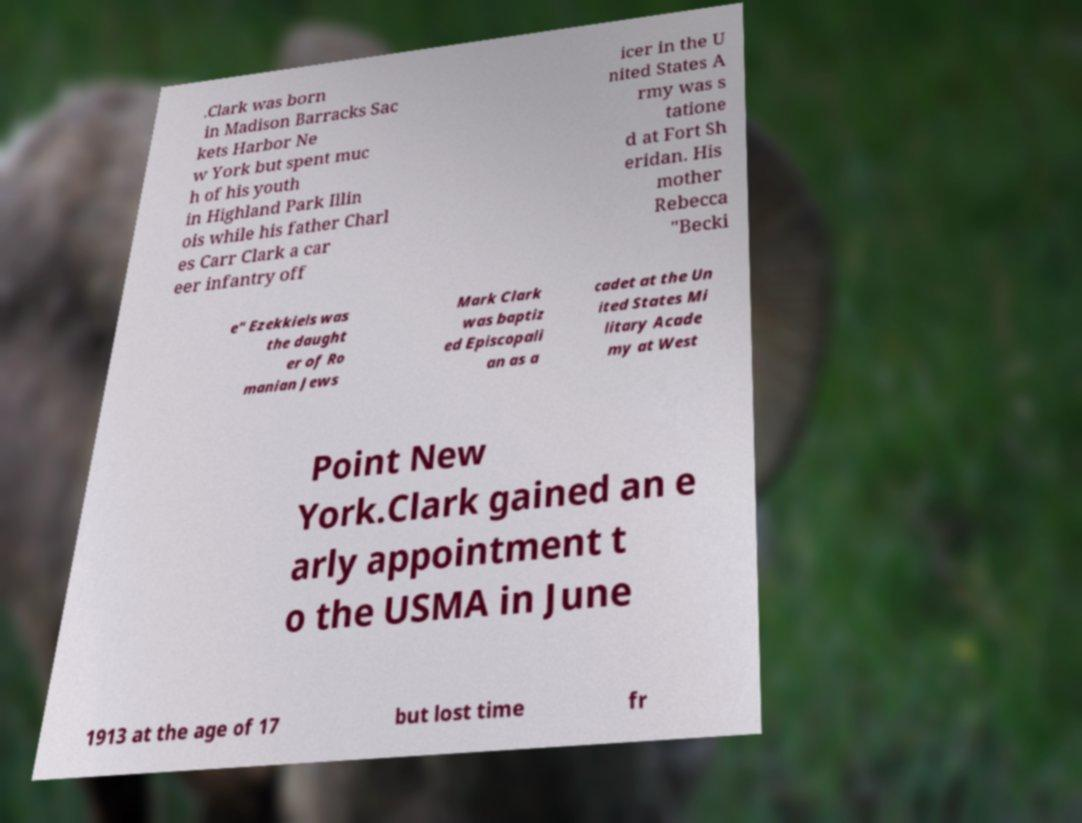What messages or text are displayed in this image? I need them in a readable, typed format. .Clark was born in Madison Barracks Sac kets Harbor Ne w York but spent muc h of his youth in Highland Park Illin ois while his father Charl es Carr Clark a car eer infantry off icer in the U nited States A rmy was s tatione d at Fort Sh eridan. His mother Rebecca "Becki e" Ezekkiels was the daught er of Ro manian Jews Mark Clark was baptiz ed Episcopali an as a cadet at the Un ited States Mi litary Acade my at West Point New York.Clark gained an e arly appointment t o the USMA in June 1913 at the age of 17 but lost time fr 